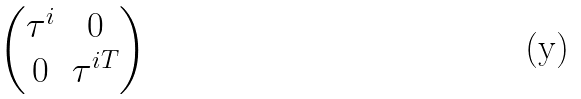<formula> <loc_0><loc_0><loc_500><loc_500>\begin{pmatrix} \tau ^ { i } & 0 \\ 0 & \tau ^ { i T } \end{pmatrix}</formula> 